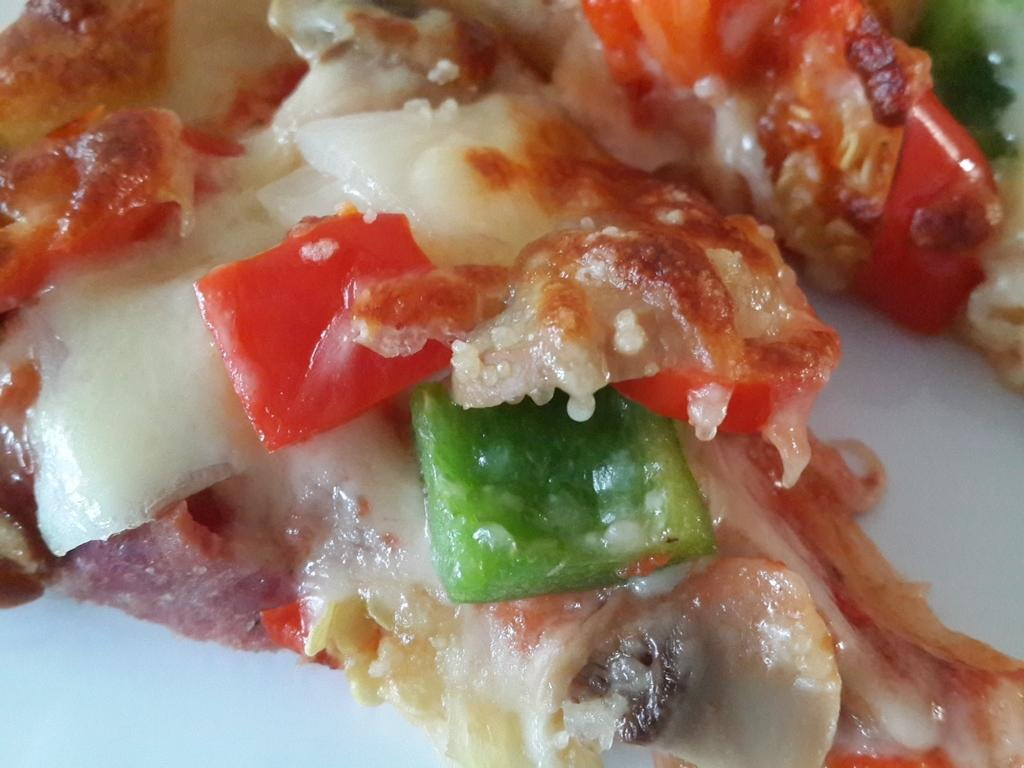What type of food is visible in the image? There is food in the image, but the specific type cannot be determined from the provided facts. What color bell peppers are present in the food? There are red and green bell peppers in the food. What color is the background below the food? The background below the food is white. Can you tell me how many cattle are visible in the image? There are no cattle present in the image. What type of stove is used to cook the food in the image? There is no stove visible in the image, and the method of cooking the food cannot be determined from the provided facts. 